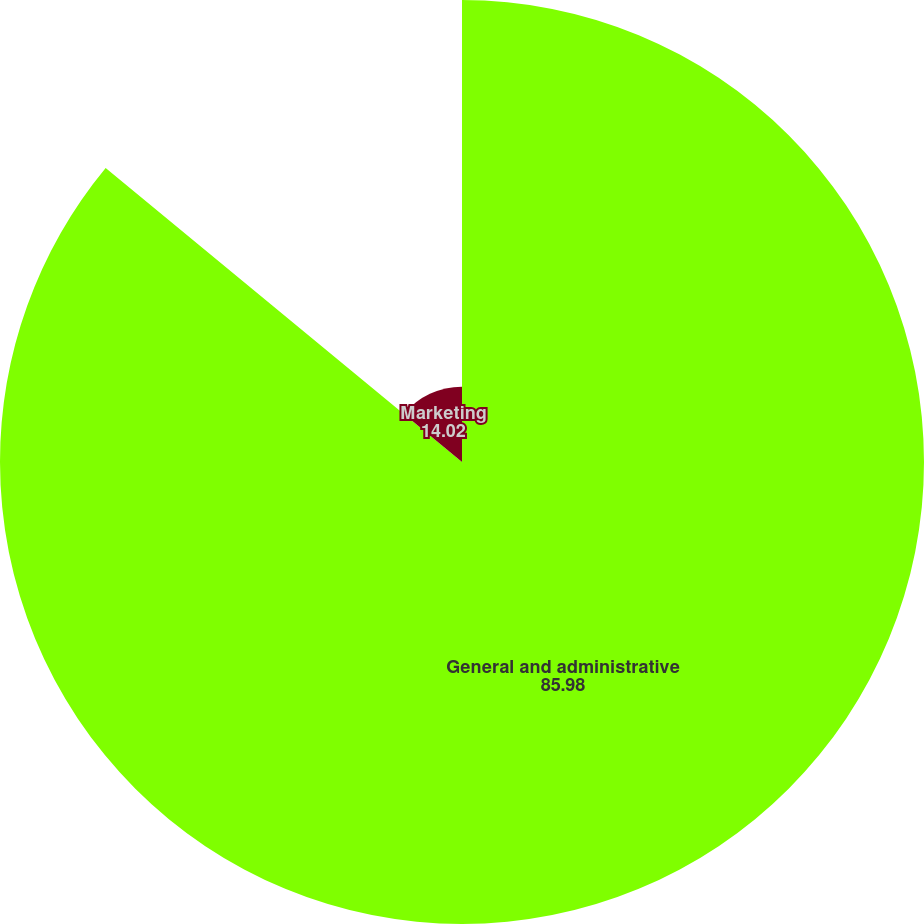Convert chart. <chart><loc_0><loc_0><loc_500><loc_500><pie_chart><fcel>General and administrative<fcel>Marketing<nl><fcel>85.98%<fcel>14.02%<nl></chart> 